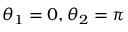<formula> <loc_0><loc_0><loc_500><loc_500>\theta _ { 1 } = 0 , \theta _ { 2 } = \pi</formula> 